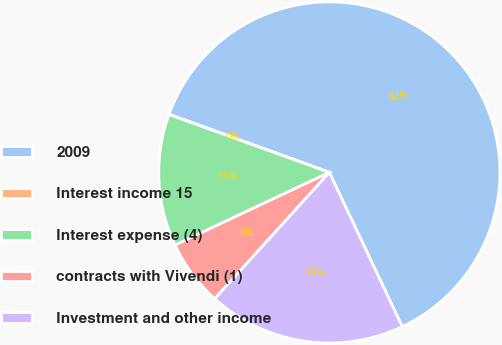Convert chart. <chart><loc_0><loc_0><loc_500><loc_500><pie_chart><fcel>2009<fcel>Interest income 15<fcel>Interest expense (4)<fcel>contracts with Vivendi (1)<fcel>Investment and other income<nl><fcel>62.43%<fcel>0.03%<fcel>12.51%<fcel>6.27%<fcel>18.75%<nl></chart> 